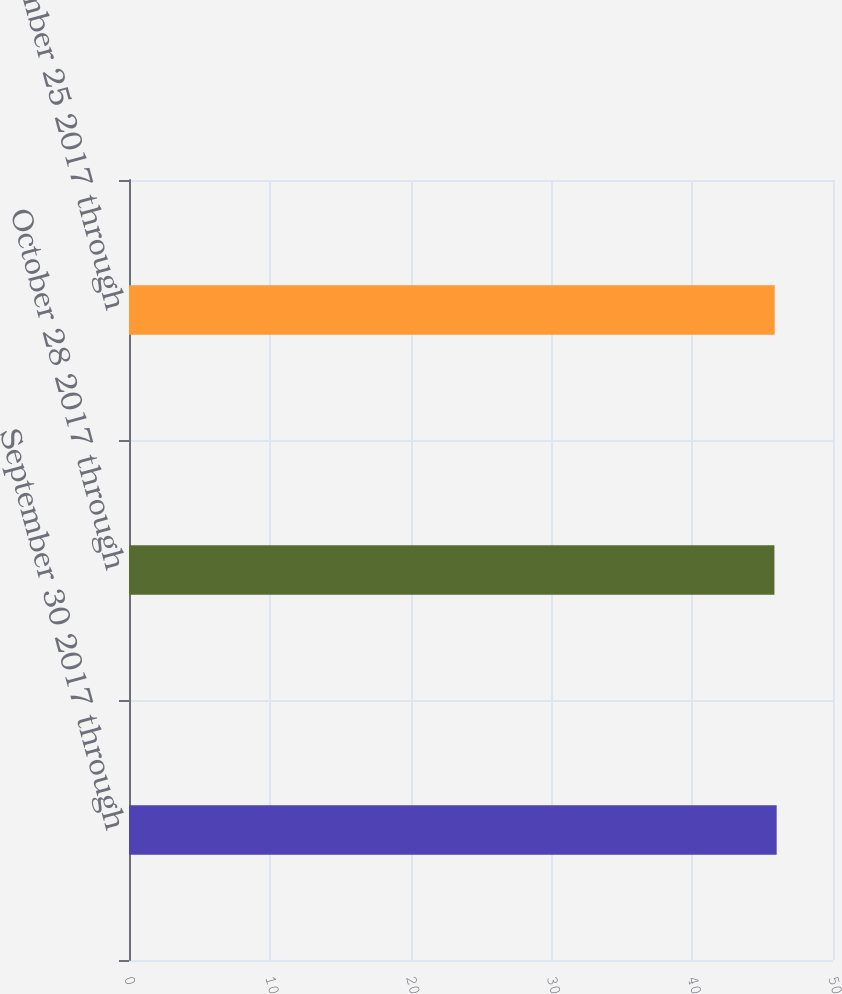Convert chart. <chart><loc_0><loc_0><loc_500><loc_500><bar_chart><fcel>September 30 2017 through<fcel>October 28 2017 through<fcel>November 25 2017 through<nl><fcel>46<fcel>45.84<fcel>45.86<nl></chart> 